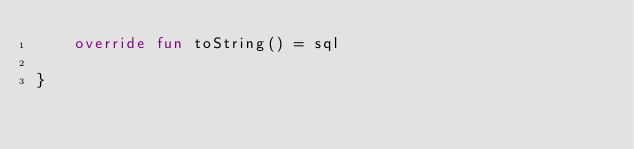Convert code to text. <code><loc_0><loc_0><loc_500><loc_500><_Kotlin_>    override fun toString() = sql

}</code> 